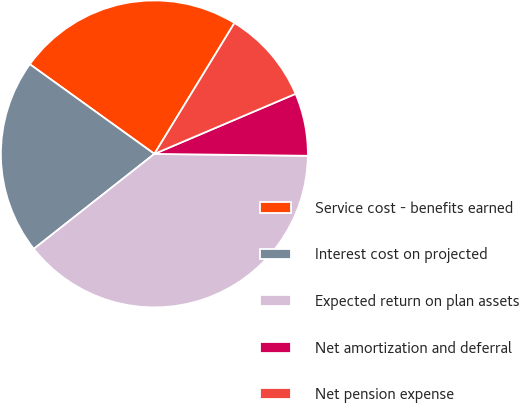Convert chart to OTSL. <chart><loc_0><loc_0><loc_500><loc_500><pie_chart><fcel>Service cost - benefits earned<fcel>Interest cost on projected<fcel>Expected return on plan assets<fcel>Net amortization and deferral<fcel>Net pension expense<nl><fcel>23.81%<fcel>20.55%<fcel>39.19%<fcel>6.6%<fcel>9.86%<nl></chart> 